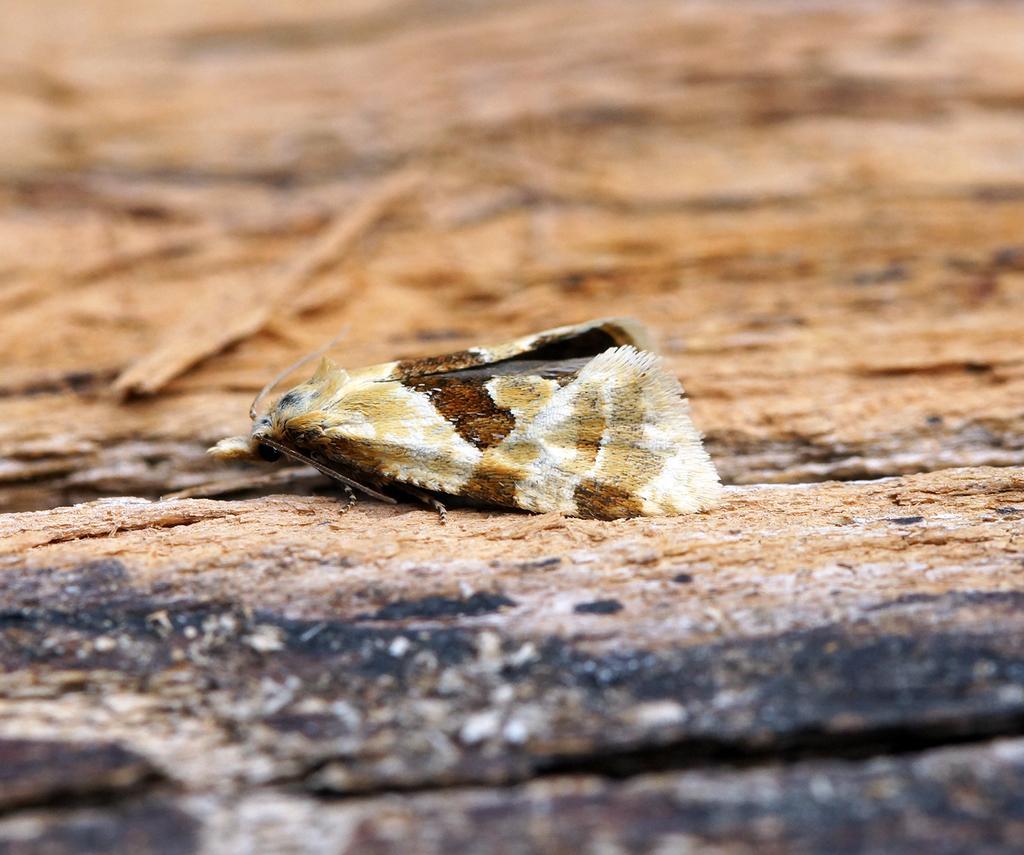In one or two sentences, can you explain what this image depicts? In the picture there is a creature laying on a rock surface. 